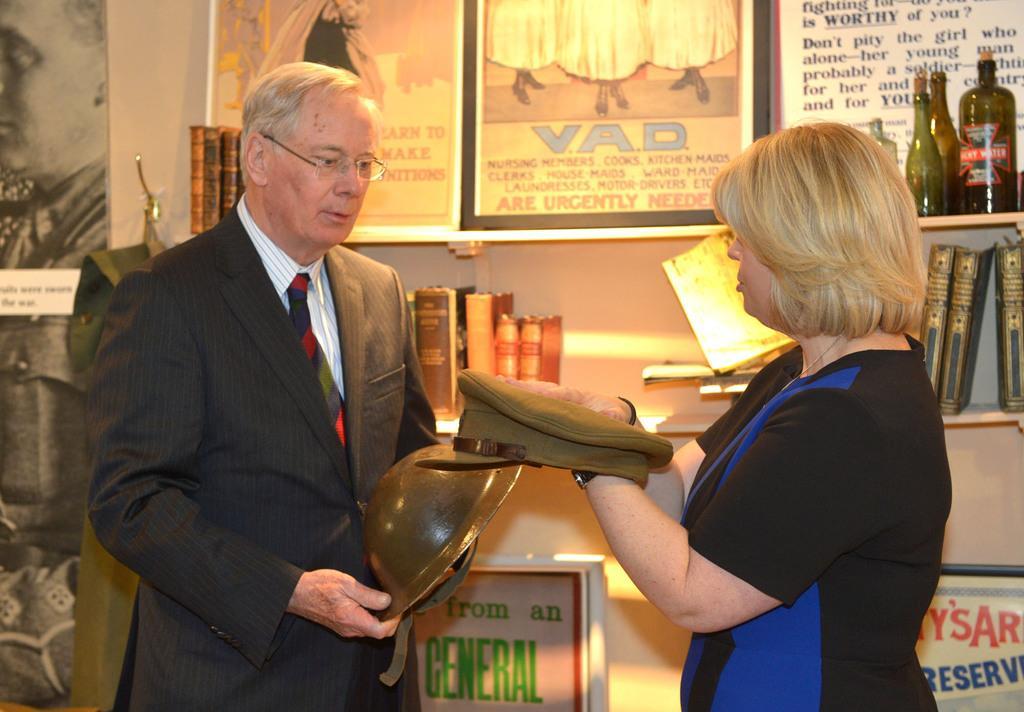Could you give a brief overview of what you see in this image? In this image I can see a man wearing shirt, tie and blazer and a woman wearing blue and black colored dress are standing and holding hats in their hands. In the background I can see few bottles and few books in the shelves, the wall and few boards attached to the wall. 